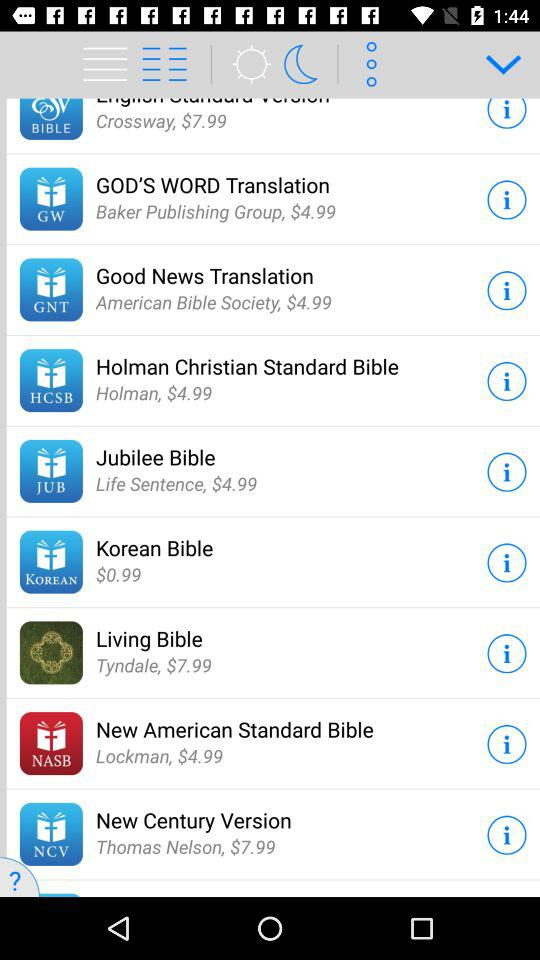What is the price of the "Korean Bible"? The price is $0.99. 